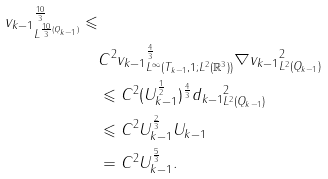<formula> <loc_0><loc_0><loc_500><loc_500>\| v _ { k - 1 } \| _ { L ^ { \frac { 1 0 } { 3 } ( Q _ { k - 1 } ) } } ^ { \frac { 1 0 } { 3 } } \leqslant \\ & C ^ { 2 } \| v _ { k - 1 } \| _ { L ^ { \infty } ( T _ { k - 1 } , 1 ; L ^ { 2 } ( \mathbb { R } ^ { 3 } ) ) } ^ { \frac { 4 } { 3 } } \| \nabla v _ { k - 1 } \| _ { L ^ { 2 } ( Q _ { k - 1 } ) } ^ { 2 } \\ & \leqslant C ^ { 2 } ( U _ { k - 1 } ^ { \frac { 1 } { 2 } } ) ^ { \frac { 4 } { 3 } } \| d _ { k - 1 } \| _ { L ^ { 2 } ( Q _ { k - 1 } ) } ^ { 2 } \\ & \leqslant C ^ { 2 } U _ { k - 1 } ^ { \frac { 2 } { 3 } } U _ { k - 1 } \\ & = C ^ { 2 } U _ { k - 1 } ^ { \frac { 5 } { 3 } } .</formula> 